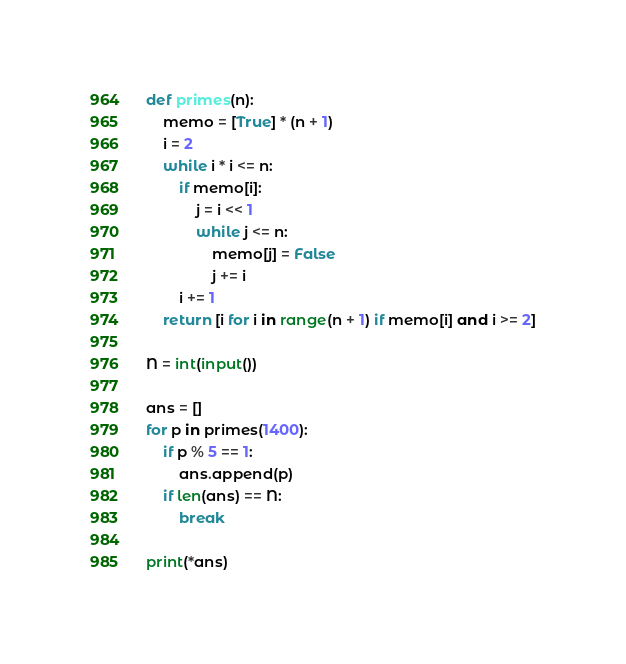<code> <loc_0><loc_0><loc_500><loc_500><_Python_>def primes(n):
    memo = [True] * (n + 1)
    i = 2
    while i * i <= n:
        if memo[i]:
            j = i << 1
            while j <= n:
                memo[j] = False
                j += i
        i += 1
    return [i for i in range(n + 1) if memo[i] and i >= 2]

N = int(input())

ans = []
for p in primes(1400):
    if p % 5 == 1:
        ans.append(p)
    if len(ans) == N:
        break

print(*ans)
</code> 